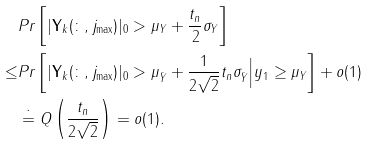<formula> <loc_0><loc_0><loc_500><loc_500>& P r \left [ | { \mathbf Y _ { k } ( \colon , j _ { \max } ) } | _ { 0 } > \mu _ { Y } + \frac { t _ { n } } { 2 } \sigma _ { Y } \right ] \\ \leq & P r \left [ | { \mathbf Y _ { k } ( \colon , j _ { \max } ) } | _ { 0 } > \mu _ { \bar { Y } } + \frac { 1 } { 2 \sqrt { 2 } } t _ { n } \sigma _ { \bar { Y } } \Big | y _ { 1 } \geq \mu _ { Y } \right ] + o ( 1 ) \\ & \doteq Q \left ( \frac { t _ { n } } { 2 \sqrt { 2 } } \right ) = o ( 1 ) .</formula> 